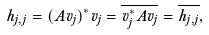<formula> <loc_0><loc_0><loc_500><loc_500>h _ { j , j } = ( A v _ { j } ) ^ { * } v _ { j } = { \overline { { v _ { j } ^ { * } A v _ { j } } } } = { \overline { { h _ { j , j } } } } ,</formula> 